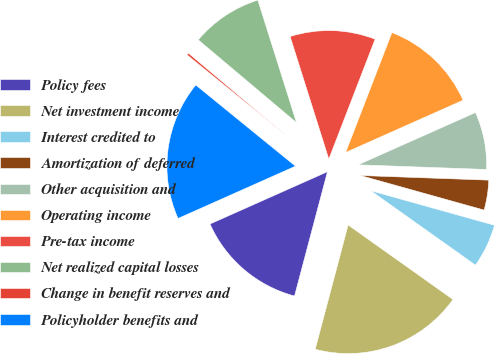Convert chart to OTSL. <chart><loc_0><loc_0><loc_500><loc_500><pie_chart><fcel>Policy fees<fcel>Net investment income<fcel>Interest credited to<fcel>Amortization of deferred<fcel>Other acquisition and<fcel>Operating income<fcel>Pre-tax income<fcel>Net realized capital losses<fcel>Change in benefit reserves and<fcel>Policyholder benefits and<nl><fcel>14.21%<fcel>19.29%<fcel>5.5%<fcel>3.76%<fcel>7.24%<fcel>12.47%<fcel>10.73%<fcel>8.99%<fcel>0.27%<fcel>17.54%<nl></chart> 